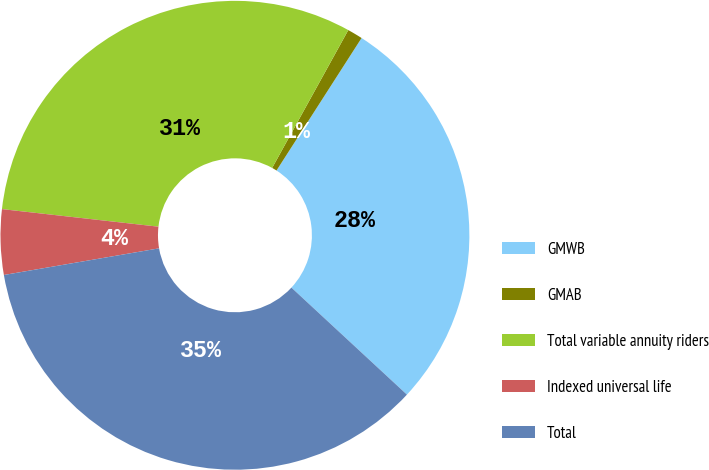Convert chart. <chart><loc_0><loc_0><loc_500><loc_500><pie_chart><fcel>GMWB<fcel>GMAB<fcel>Total variable annuity riders<fcel>Indexed universal life<fcel>Total<nl><fcel>27.81%<fcel>1.05%<fcel>31.25%<fcel>4.49%<fcel>35.4%<nl></chart> 